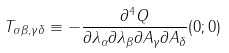Convert formula to latex. <formula><loc_0><loc_0><loc_500><loc_500>T _ { \alpha \beta , \gamma \delta } \equiv - \frac { \partial ^ { 4 } Q } { \partial \lambda _ { \alpha } \partial \lambda _ { \beta } \partial A _ { \gamma } \partial A _ { \delta } } ( 0 ; 0 )</formula> 